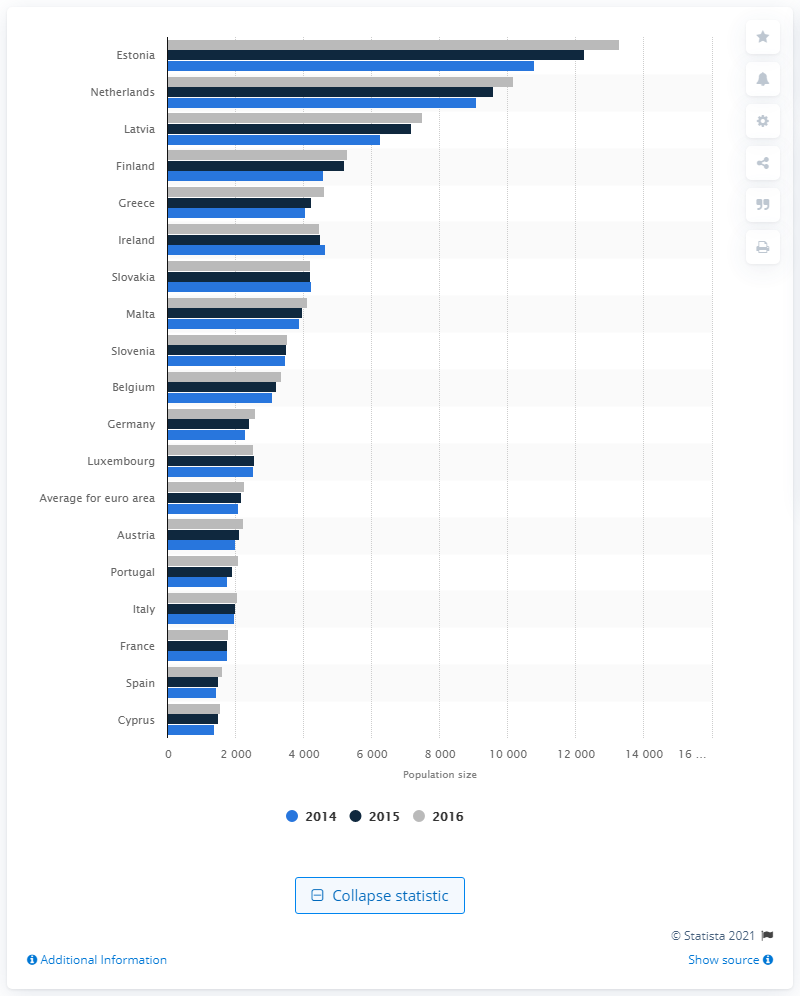Draw attention to some important aspects in this diagram. In 2016, the average number of people served by each local bank in Estonia was approximately 13,292. 